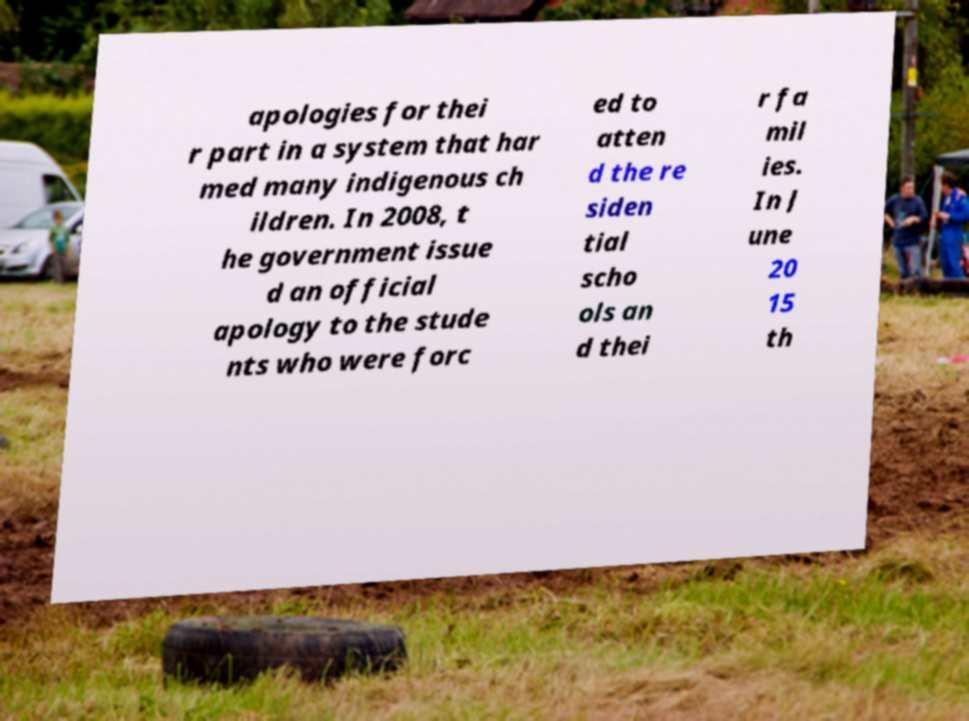Please identify and transcribe the text found in this image. apologies for thei r part in a system that har med many indigenous ch ildren. In 2008, t he government issue d an official apology to the stude nts who were forc ed to atten d the re siden tial scho ols an d thei r fa mil ies. In J une 20 15 th 